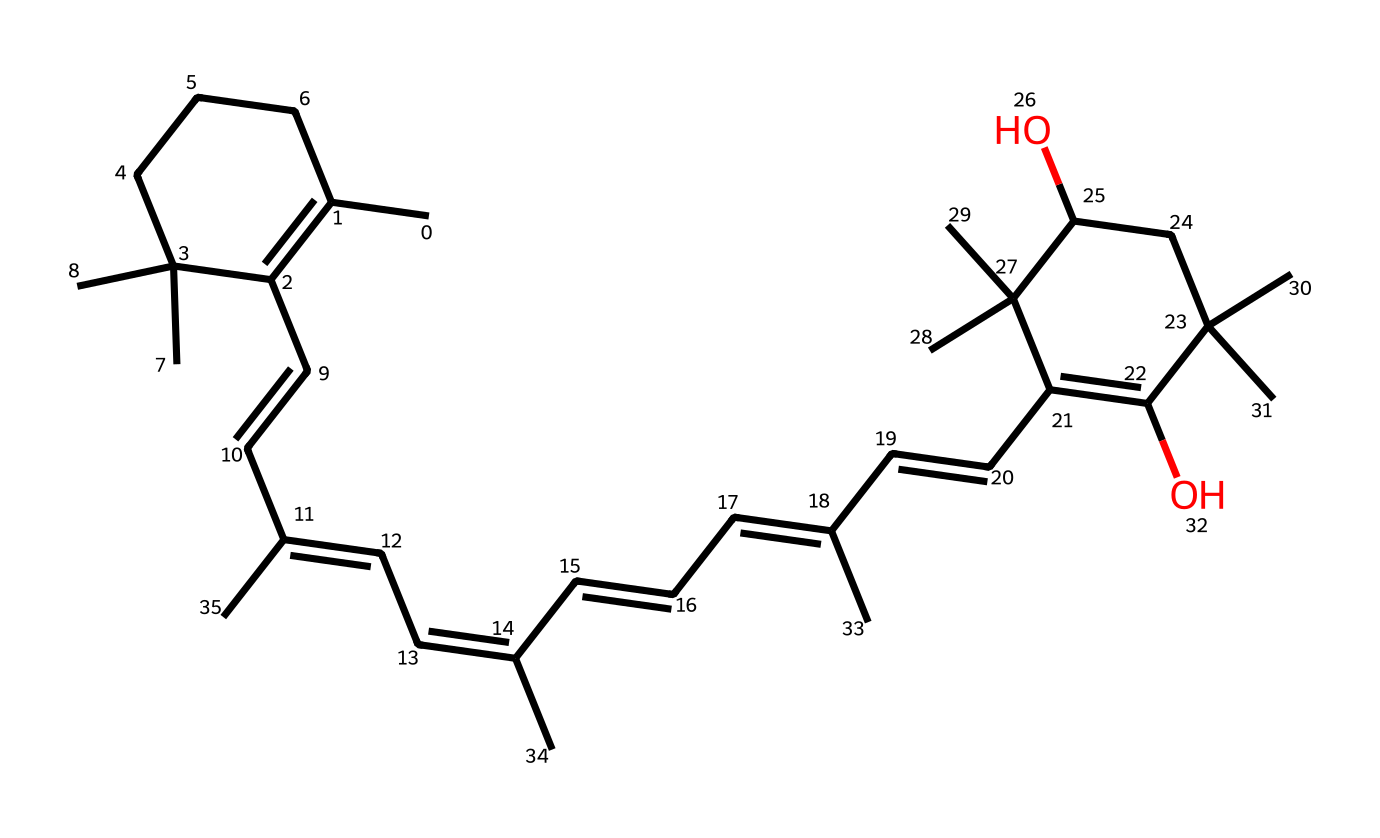What is the molecular formula of astaxanthin? To find the molecular formula, the number of carbon (C), hydrogen (H), and oxygen (O) atoms needs to be counted from the provided SMILES representation. In this case, there are 40 carbon atoms, 52 hydrogen atoms, and 4 oxygen atoms, which gives the molecular formula C40H52O4.
Answer: C40H52O4 How many cyclic structures are present in astaxanthin? By examining the chemical structure, it can be identified that there are two distinct cyclic structures due to the presence of double bonds and closed ring formations. These help in stabilizing the molecule and contribute to its antioxidant properties.
Answer: 2 What type of antioxidant is astaxanthin categorized as? Astaxanthin is categorized as a carotenoid, which is a class of antioxidants known for their role in protecting against oxidative stress within cells. The unique structure of astaxanthin contributes to its high antioxidant capacity.
Answer: carotenoid How many conjugated double bonds are present in astaxanthin? The structure displays a series of alternating double bonds that make it conjugated. Counting these bonds shows that there are 9 conjugated double bonds that contribute to its electron delocalization and antioxidant properties.
Answer: 9 What functional groups are present in the astaxanthin structure? In astaxanthin, there are hydroxyl (–OH) groups attached to the cyclic structures. The presence of these functional groups is critical for its activity as an antioxidant, as they can donate hydrogen to free radicals.
Answer: hydroxyl groups What role does the unique structure of astaxanthin play in its antioxidant activity? The unique structure with multiple conjugated double bonds allows for effective electron transfer, which is essential for neutralizing free radicals. This structural feature enhances its ability to scavenge reactive species and reduce oxidative stress within the body.
Answer: electron transfer 